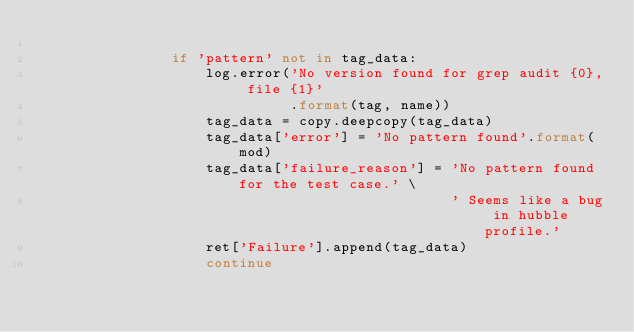<code> <loc_0><loc_0><loc_500><loc_500><_Python_>
                if 'pattern' not in tag_data:
                    log.error('No version found for grep audit {0}, file {1}'
                              .format(tag, name))
                    tag_data = copy.deepcopy(tag_data)
                    tag_data['error'] = 'No pattern found'.format(mod)
                    tag_data['failure_reason'] = 'No pattern found for the test case.' \
                                                 ' Seems like a bug in hubble profile.'
                    ret['Failure'].append(tag_data)
                    continue
</code> 